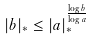<formula> <loc_0><loc_0><loc_500><loc_500>| b | _ { * } \leq | a | _ { * } ^ { \frac { \log b } { \log a } }</formula> 